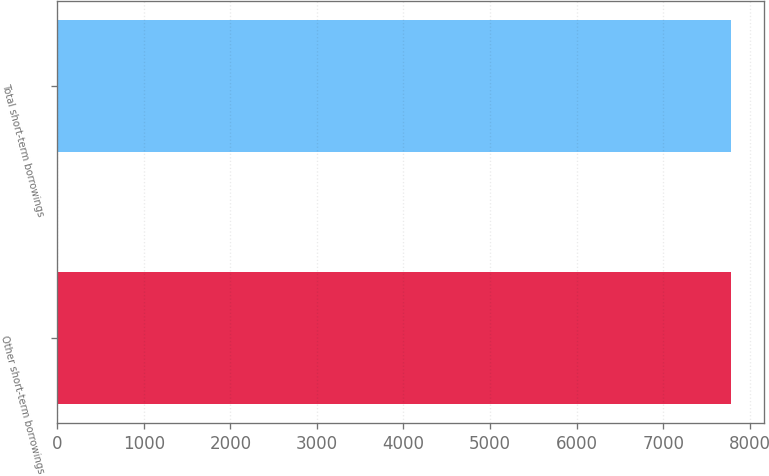<chart> <loc_0><loc_0><loc_500><loc_500><bar_chart><fcel>Other short-term borrowings<fcel>Total short-term borrowings<nl><fcel>7781<fcel>7781.1<nl></chart> 